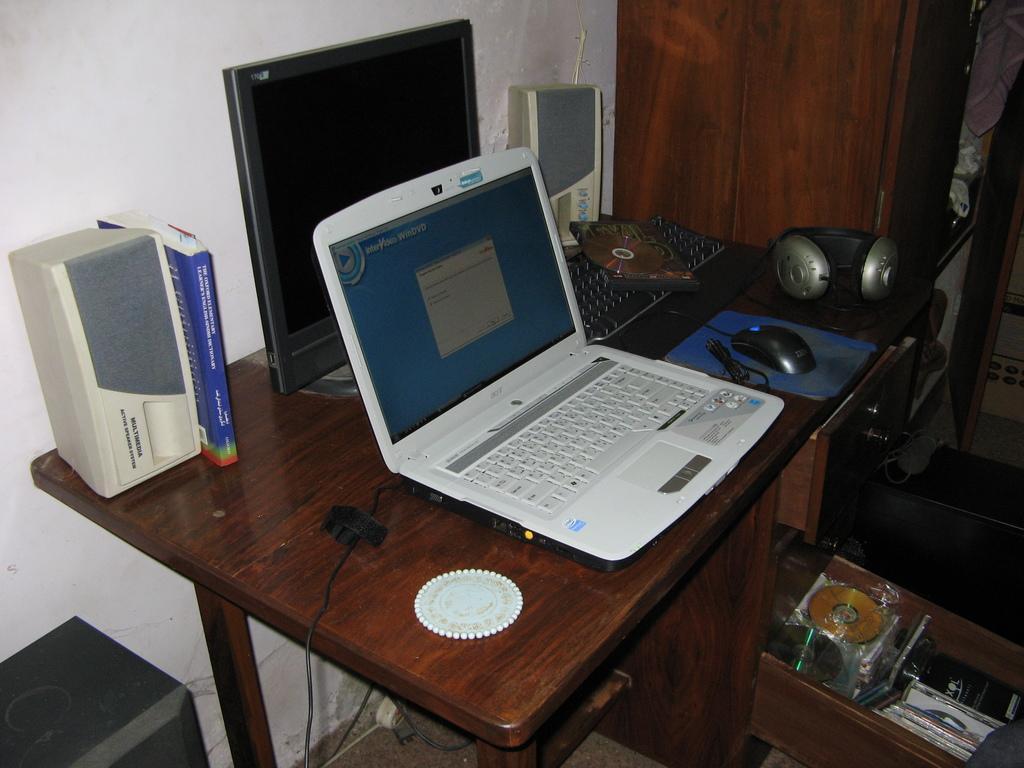Can you describe this image briefly? This image is taken inside a room. There are many things visible in this room. In the left side of the image at the bottom there is a speaker box. In the middle of the image there is a table which has laptop, small plate, a book, monitor, key board, CD, small speaker box, headsets, mouse and a mouse pad were present on it. In the right side of the image table drawer is present and there are few things in it and there is a cupboard with few shelves. 